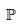<formula> <loc_0><loc_0><loc_500><loc_500>\mathbb { P }</formula> 